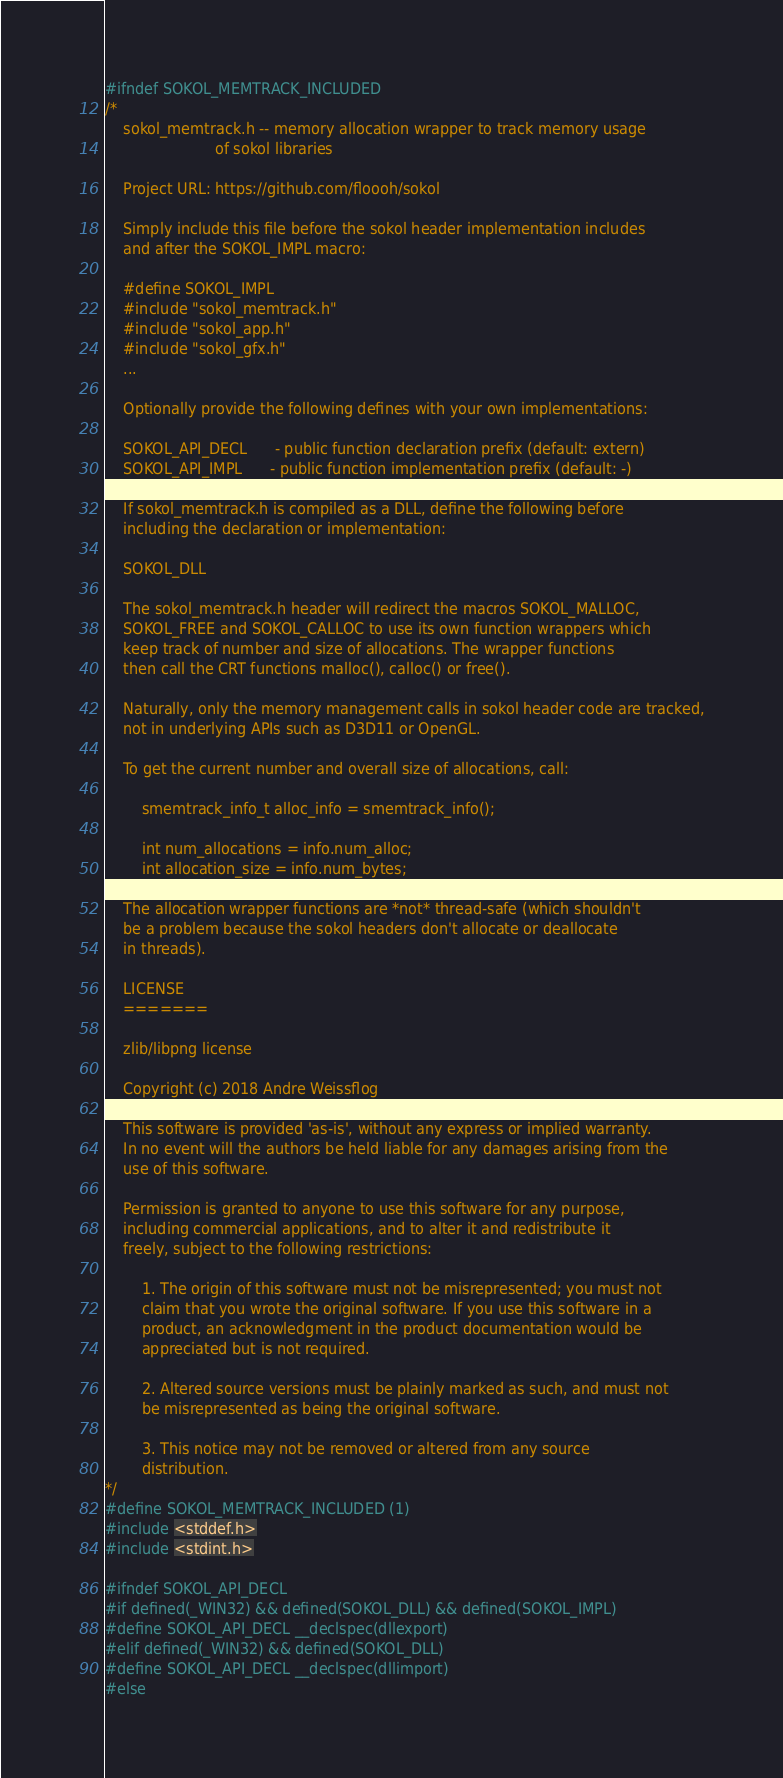<code> <loc_0><loc_0><loc_500><loc_500><_C_>#ifndef SOKOL_MEMTRACK_INCLUDED
/*
    sokol_memtrack.h -- memory allocation wrapper to track memory usage
                        of sokol libraries

    Project URL: https://github.com/floooh/sokol

    Simply include this file before the sokol header implementation includes
    and after the SOKOL_IMPL macro:

    #define SOKOL_IMPL
    #include "sokol_memtrack.h"
    #include "sokol_app.h"
    #include "sokol_gfx.h"
    ...

    Optionally provide the following defines with your own implementations:

    SOKOL_API_DECL      - public function declaration prefix (default: extern)
    SOKOL_API_IMPL      - public function implementation prefix (default: -)

    If sokol_memtrack.h is compiled as a DLL, define the following before
    including the declaration or implementation:

    SOKOL_DLL

    The sokol_memtrack.h header will redirect the macros SOKOL_MALLOC,
    SOKOL_FREE and SOKOL_CALLOC to use its own function wrappers which
    keep track of number and size of allocations. The wrapper functions
    then call the CRT functions malloc(), calloc() or free().

    Naturally, only the memory management calls in sokol header code are tracked,
    not in underlying APIs such as D3D11 or OpenGL.

    To get the current number and overall size of allocations, call:

        smemtrack_info_t alloc_info = smemtrack_info();

        int num_allocations = info.num_alloc;
        int allocation_size = info.num_bytes;

    The allocation wrapper functions are *not* thread-safe (which shouldn't
    be a problem because the sokol headers don't allocate or deallocate
    in threads).

    LICENSE
    =======

    zlib/libpng license

    Copyright (c) 2018 Andre Weissflog

    This software is provided 'as-is', without any express or implied warranty.
    In no event will the authors be held liable for any damages arising from the
    use of this software.

    Permission is granted to anyone to use this software for any purpose,
    including commercial applications, and to alter it and redistribute it
    freely, subject to the following restrictions:

        1. The origin of this software must not be misrepresented; you must not
        claim that you wrote the original software. If you use this software in a
        product, an acknowledgment in the product documentation would be
        appreciated but is not required.

        2. Altered source versions must be plainly marked as such, and must not
        be misrepresented as being the original software.

        3. This notice may not be removed or altered from any source
        distribution.
*/
#define SOKOL_MEMTRACK_INCLUDED (1)
#include <stddef.h>
#include <stdint.h>

#ifndef SOKOL_API_DECL
#if defined(_WIN32) && defined(SOKOL_DLL) && defined(SOKOL_IMPL)
#define SOKOL_API_DECL __declspec(dllexport)
#elif defined(_WIN32) && defined(SOKOL_DLL)
#define SOKOL_API_DECL __declspec(dllimport)
#else</code> 